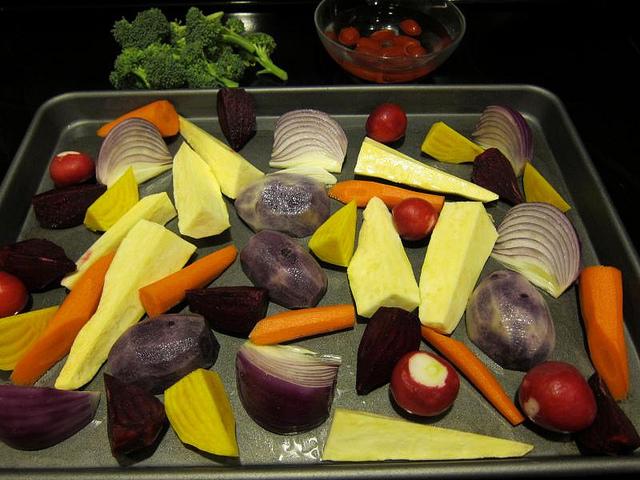How many pieces of food are in this scene ??
Write a very short answer. 20. Are there carrots on the tray?
Give a very brief answer. Yes. What green vegetable is not on the tray?
Give a very brief answer. Broccoli. 